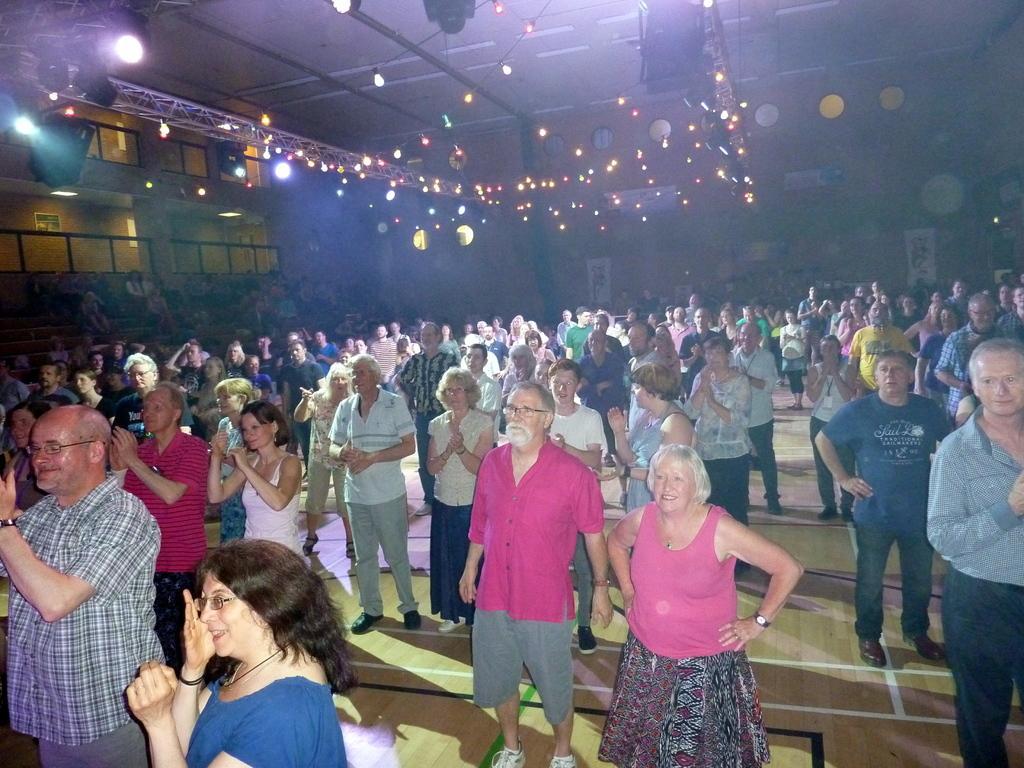Describe this image in one or two sentences. In this image we can see a group of people standing on the floor. On the left side of the image we can see some audience sitting, barricades. In the background, we can see a poster with some pictures. At the top of the image we can see some lights. 